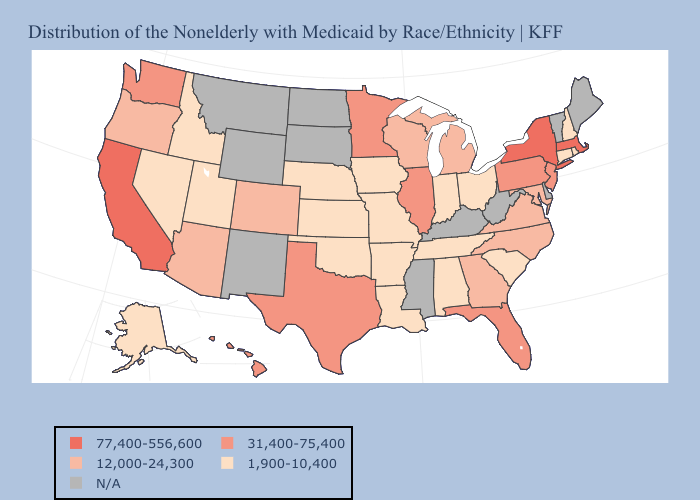Which states have the highest value in the USA?
Write a very short answer. California, Massachusetts, New York. Name the states that have a value in the range 77,400-556,600?
Be succinct. California, Massachusetts, New York. Name the states that have a value in the range 1,900-10,400?
Write a very short answer. Alabama, Alaska, Arkansas, Connecticut, Idaho, Indiana, Iowa, Kansas, Louisiana, Missouri, Nebraska, Nevada, New Hampshire, Ohio, Oklahoma, Rhode Island, South Carolina, Tennessee, Utah. What is the lowest value in states that border Georgia?
Concise answer only. 1,900-10,400. Which states hav the highest value in the South?
Write a very short answer. Florida, Texas. Among the states that border Indiana , does Ohio have the lowest value?
Keep it brief. Yes. Name the states that have a value in the range 1,900-10,400?
Write a very short answer. Alabama, Alaska, Arkansas, Connecticut, Idaho, Indiana, Iowa, Kansas, Louisiana, Missouri, Nebraska, Nevada, New Hampshire, Ohio, Oklahoma, Rhode Island, South Carolina, Tennessee, Utah. What is the value of Wyoming?
Answer briefly. N/A. Does California have the highest value in the USA?
Write a very short answer. Yes. What is the value of Alaska?
Short answer required. 1,900-10,400. What is the lowest value in states that border New Mexico?
Write a very short answer. 1,900-10,400. What is the lowest value in the USA?
Keep it brief. 1,900-10,400. Among the states that border Oklahoma , does Texas have the highest value?
Keep it brief. Yes. Does the first symbol in the legend represent the smallest category?
Quick response, please. No. 